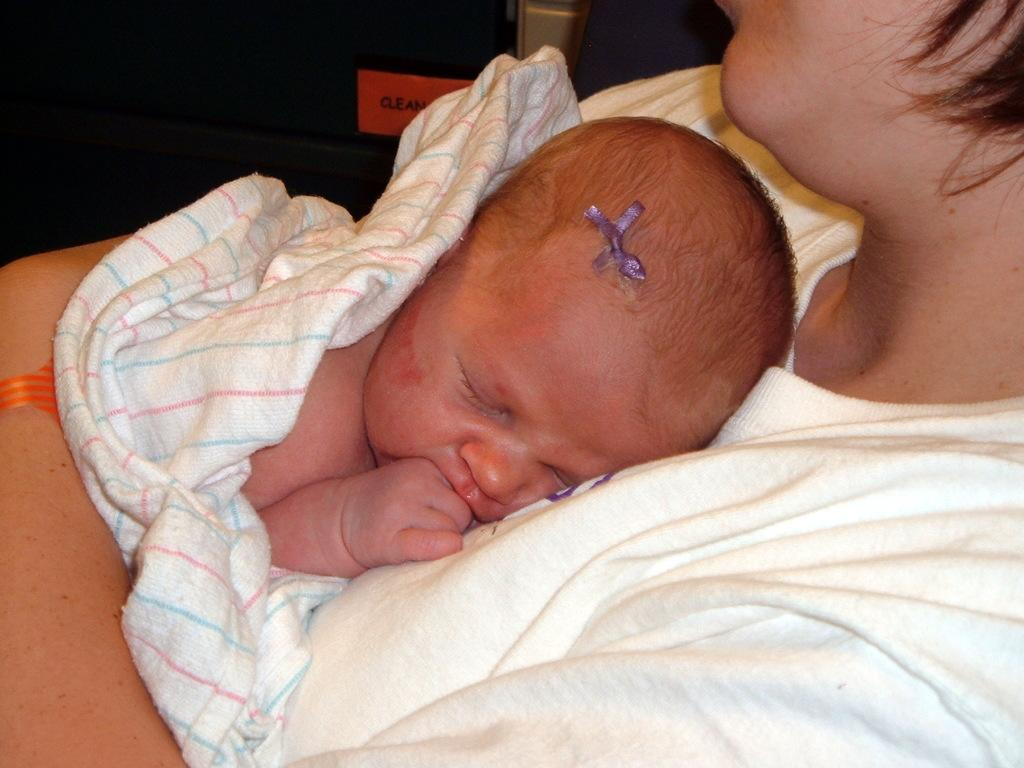What is the main subject of the image? There is a person truncated towards the right of the image. Can you describe what the person is doing? The person is not fully visible, but they appear to be standing or walking. What else can be seen in the image? There is a baby sleeping in the image. What is the condition of the object in the background? The object is truncated, so it is not fully visible. How many ants can be seen crawling on the wound in the image? There is no wound or ants present in the image. 